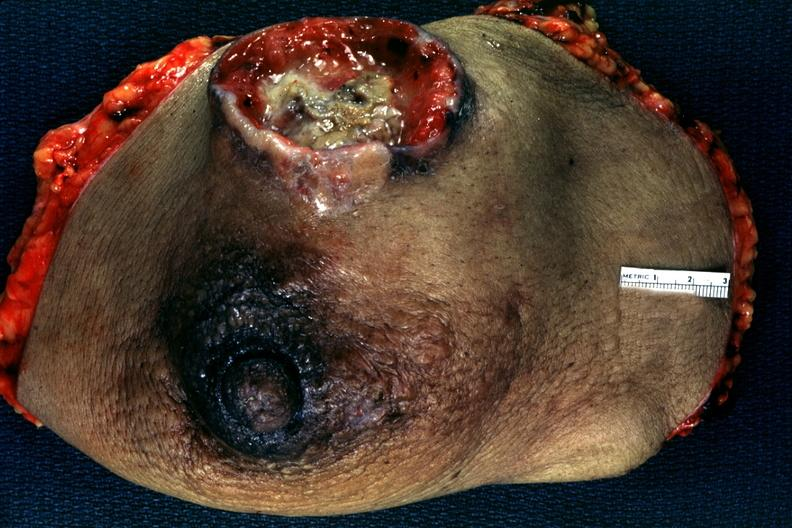what is present?
Answer the question using a single word or phrase. Breast 